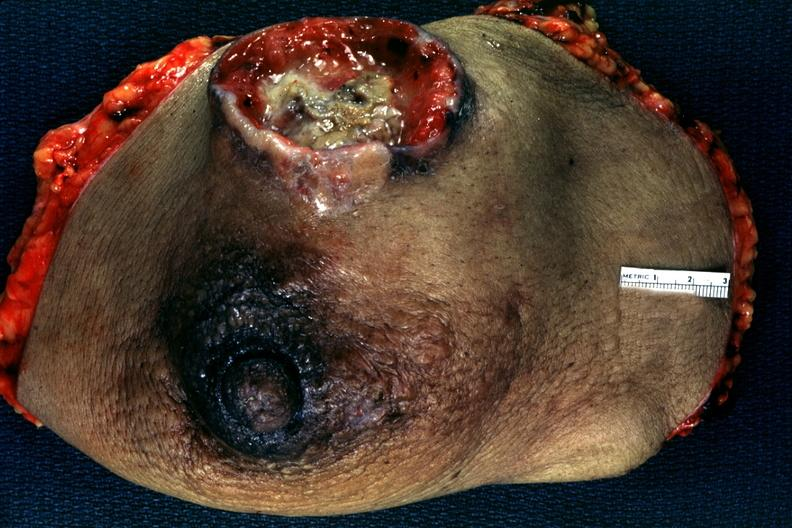what is present?
Answer the question using a single word or phrase. Breast 